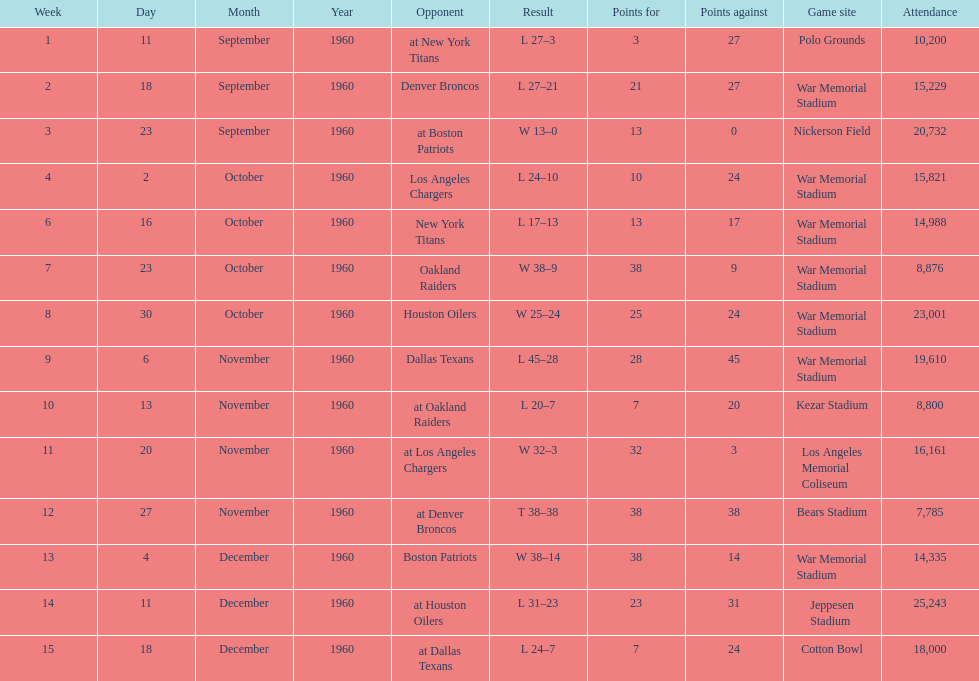Who did the bills play after the oakland raiders? Houston Oilers. 